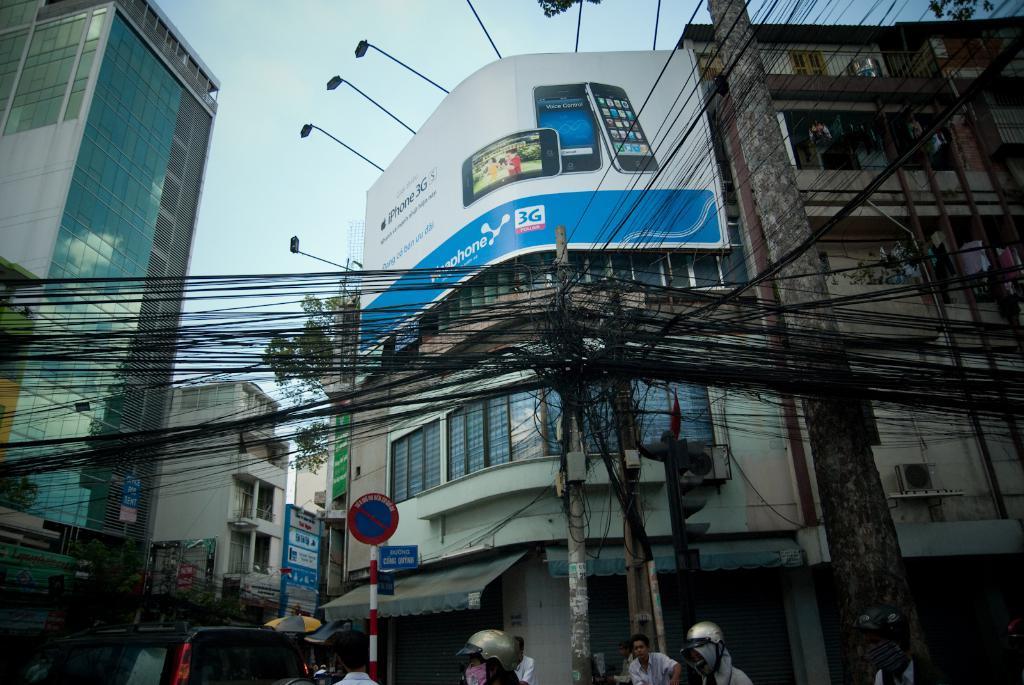Please provide a concise description of this image. There are electric poles with wires. Also at the bottom we can see a vehicle, sign board with pole and few people. Some are wearing helmets. In the back there are buildings with name boards and lights. Also there is a tree and there is sky. 